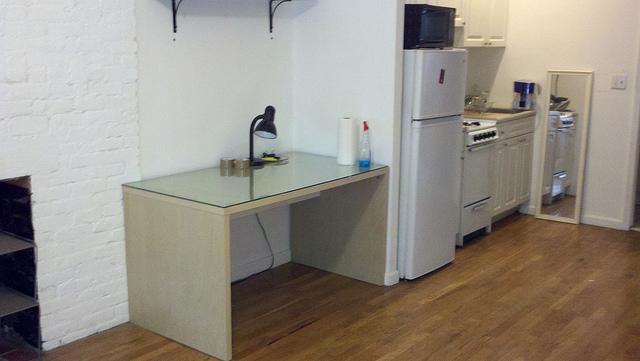What is in the bottle on the desk?
Concise answer only. Windex. What color is the fridge?
Keep it brief. White. What color is the desk lamp?
Short answer required. Black. How many doors does the fridge have?
Keep it brief. 2. What is above the microwave?
Give a very brief answer. Cabinet. Does this kitchen look expensive?
Short answer required. No. Where is the microwave?
Quick response, please. On fridge. 